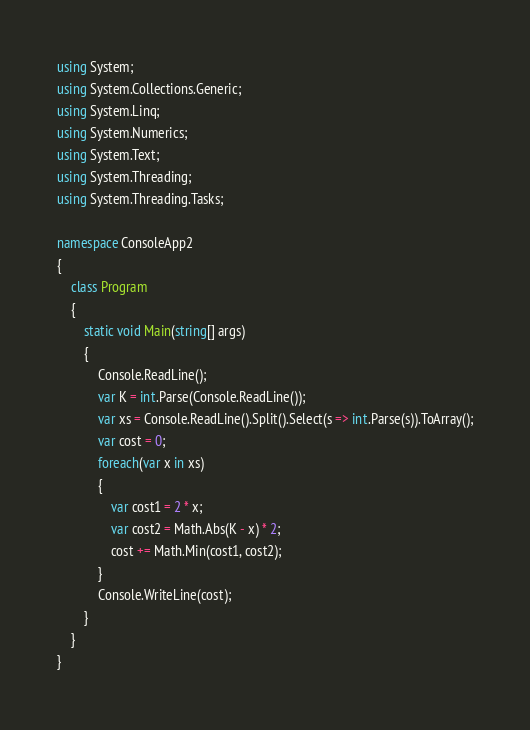Convert code to text. <code><loc_0><loc_0><loc_500><loc_500><_C#_>using System;
using System.Collections.Generic;
using System.Linq;
using System.Numerics;
using System.Text;
using System.Threading;
using System.Threading.Tasks;

namespace ConsoleApp2
{
    class Program
    {
        static void Main(string[] args)
        {
            Console.ReadLine();
            var K = int.Parse(Console.ReadLine());
            var xs = Console.ReadLine().Split().Select(s => int.Parse(s)).ToArray();
            var cost = 0;
            foreach(var x in xs)
            {
                var cost1 = 2 * x;
                var cost2 = Math.Abs(K - x) * 2;
                cost += Math.Min(cost1, cost2);
            }
            Console.WriteLine(cost);
        }
    }
}</code> 